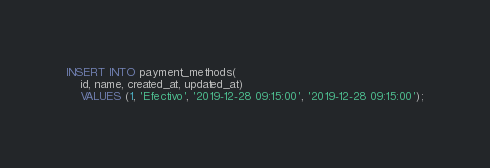<code> <loc_0><loc_0><loc_500><loc_500><_SQL_>INSERT INTO payment_methods(
	id, name, created_at, updated_at)
	VALUES (1, 'Efectivo', '2019-12-28 09:15:00', '2019-12-28 09:15:00');
</code> 